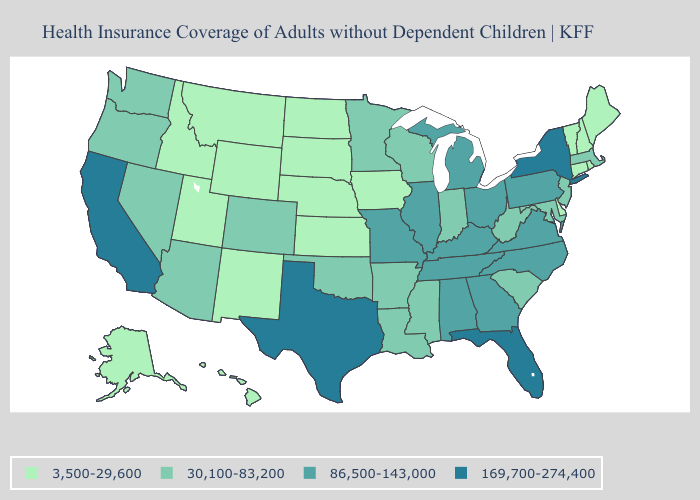How many symbols are there in the legend?
Concise answer only. 4. What is the highest value in states that border Kansas?
Write a very short answer. 86,500-143,000. Does New Mexico have the highest value in the USA?
Write a very short answer. No. Which states have the highest value in the USA?
Give a very brief answer. California, Florida, New York, Texas. Name the states that have a value in the range 3,500-29,600?
Quick response, please. Alaska, Connecticut, Delaware, Hawaii, Idaho, Iowa, Kansas, Maine, Montana, Nebraska, New Hampshire, New Mexico, North Dakota, Rhode Island, South Dakota, Utah, Vermont, Wyoming. What is the value of Wyoming?
Short answer required. 3,500-29,600. What is the lowest value in states that border Delaware?
Short answer required. 30,100-83,200. Which states have the lowest value in the South?
Answer briefly. Delaware. What is the value of Wyoming?
Concise answer only. 3,500-29,600. Does California have the lowest value in the USA?
Keep it brief. No. Does Colorado have the same value as Indiana?
Write a very short answer. Yes. Which states hav the highest value in the South?
Keep it brief. Florida, Texas. What is the value of North Dakota?
Quick response, please. 3,500-29,600. Among the states that border Oklahoma , does Colorado have the highest value?
Concise answer only. No. Name the states that have a value in the range 3,500-29,600?
Write a very short answer. Alaska, Connecticut, Delaware, Hawaii, Idaho, Iowa, Kansas, Maine, Montana, Nebraska, New Hampshire, New Mexico, North Dakota, Rhode Island, South Dakota, Utah, Vermont, Wyoming. 